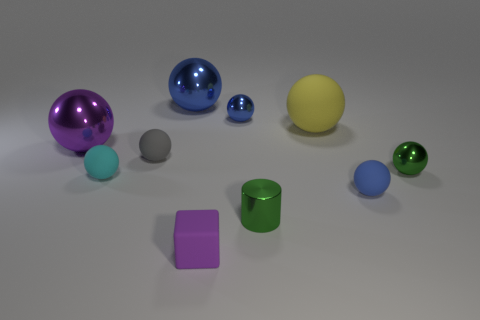Subtract all red blocks. How many blue spheres are left? 3 Subtract 5 spheres. How many spheres are left? 3 Subtract all gray spheres. How many spheres are left? 7 Subtract all gray balls. How many balls are left? 7 Subtract all red spheres. Subtract all green cubes. How many spheres are left? 8 Subtract all balls. How many objects are left? 2 Subtract all big yellow rubber cylinders. Subtract all purple rubber objects. How many objects are left? 9 Add 6 big objects. How many big objects are left? 9 Add 2 big red matte balls. How many big red matte balls exist? 2 Subtract 0 brown balls. How many objects are left? 10 